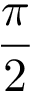Convert formula to latex. <formula><loc_0><loc_0><loc_500><loc_500>\frac { \pi } { 2 }</formula> 